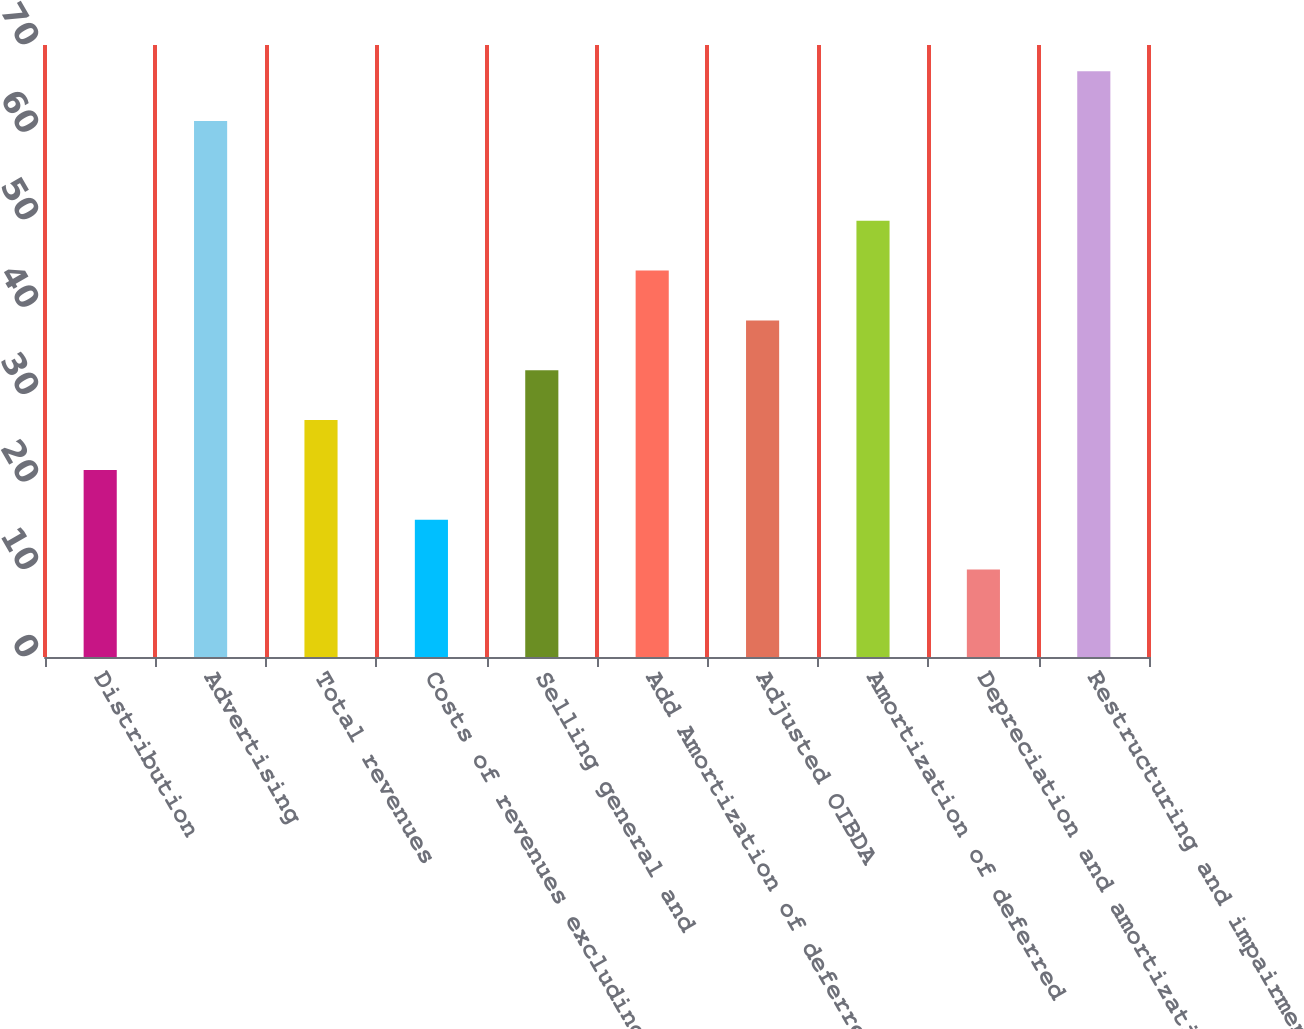Convert chart to OTSL. <chart><loc_0><loc_0><loc_500><loc_500><bar_chart><fcel>Distribution<fcel>Advertising<fcel>Total revenues<fcel>Costs of revenues excluding<fcel>Selling general and<fcel>Add Amortization of deferred<fcel>Adjusted OIBDA<fcel>Amortization of deferred<fcel>Depreciation and amortization<fcel>Restructuring and impairment<nl><fcel>21.4<fcel>61.3<fcel>27.1<fcel>15.7<fcel>32.8<fcel>44.2<fcel>38.5<fcel>49.9<fcel>10<fcel>67<nl></chart> 